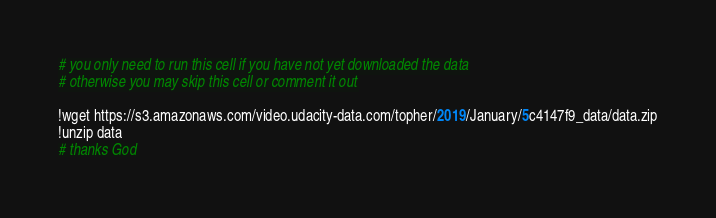<code> <loc_0><loc_0><loc_500><loc_500><_Python_># you only need to run this cell if you have not yet downloaded the data
# otherwise you may skip this cell or comment it out

!wget https://s3.amazonaws.com/video.udacity-data.com/topher/2019/January/5c4147f9_data/data.zip
!unzip data
# thanks God
</code> 